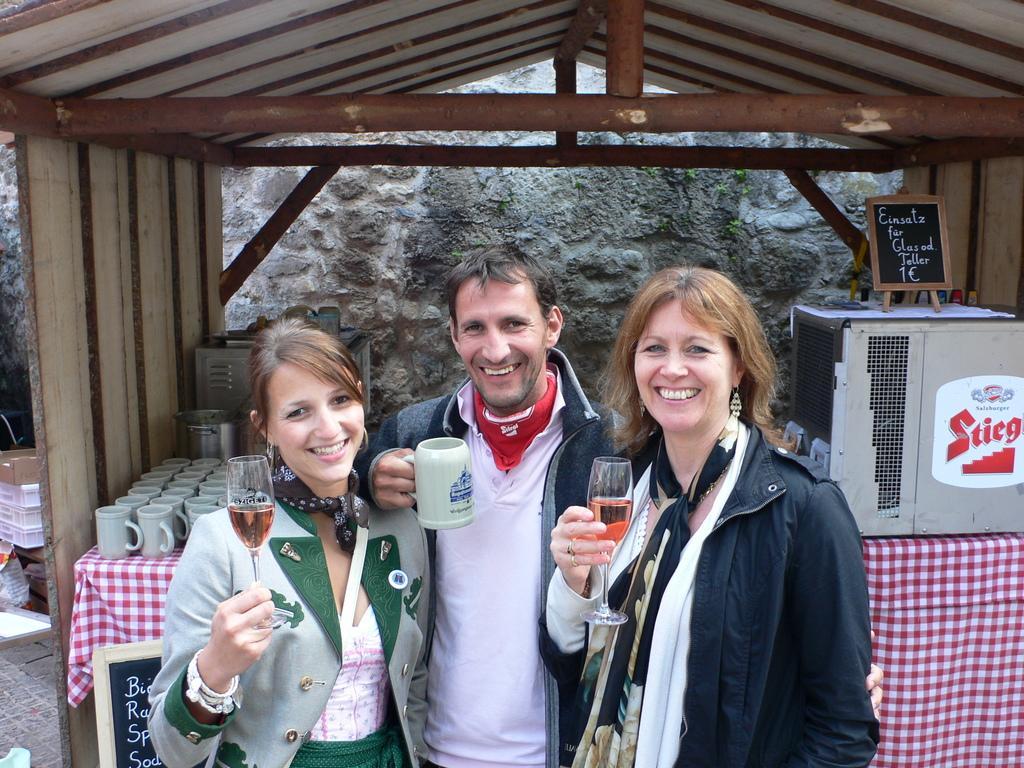How would you summarize this image in a sentence or two? In this picture we can observe three members. Two of them are women holding wine glasses in their hands. All of them are smiling. We can observe a man holding a cup in his hand. In the background we can observe wooden shed and a wall. There are some cups placed on the table in this shed. 